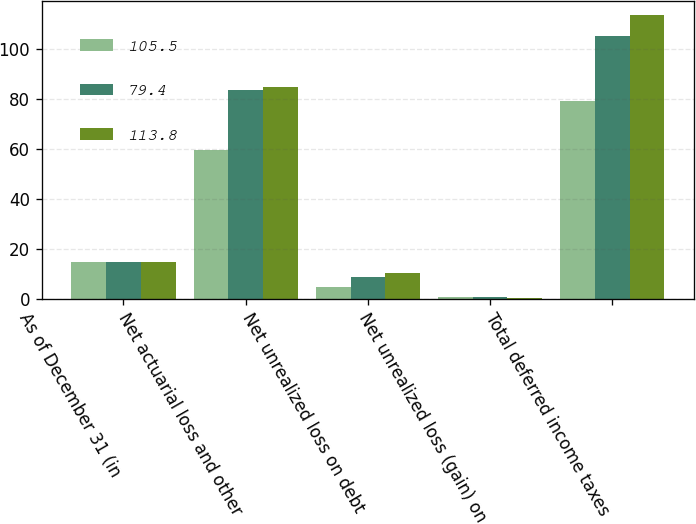Convert chart to OTSL. <chart><loc_0><loc_0><loc_500><loc_500><stacked_bar_chart><ecel><fcel>As of December 31 (in<fcel>Net actuarial loss and other<fcel>Net unrealized loss on debt<fcel>Net unrealized loss (gain) on<fcel>Total deferred income taxes<nl><fcel>105.5<fcel>14.7<fcel>59.4<fcel>4.7<fcel>0.6<fcel>79.4<nl><fcel>79.4<fcel>14.7<fcel>83.5<fcel>8.8<fcel>0.5<fcel>105.5<nl><fcel>113.8<fcel>14.7<fcel>85<fcel>10.2<fcel>0.2<fcel>113.8<nl></chart> 